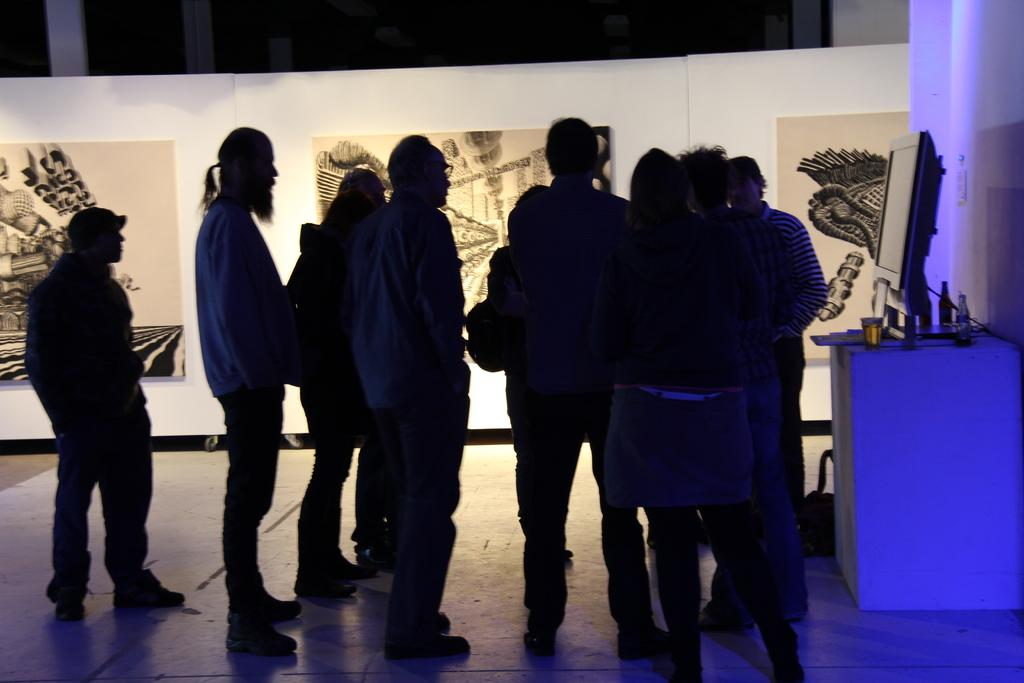How many people are in the image? There is a group of people in the image. What are the people in the image doing? The people are standing in one place. What can be seen on the table in the image? A system (possibly a computer or electronic device) is placed on the table. What is visible on the wall in the background? There are banners visible on a wall in the background. What type of scarecrow is standing next to the table in the image? There is no scarecrow present in the image. What flavor of ice cream is being served at the event in the image? There is no mention of ice cream or any food in the image. 